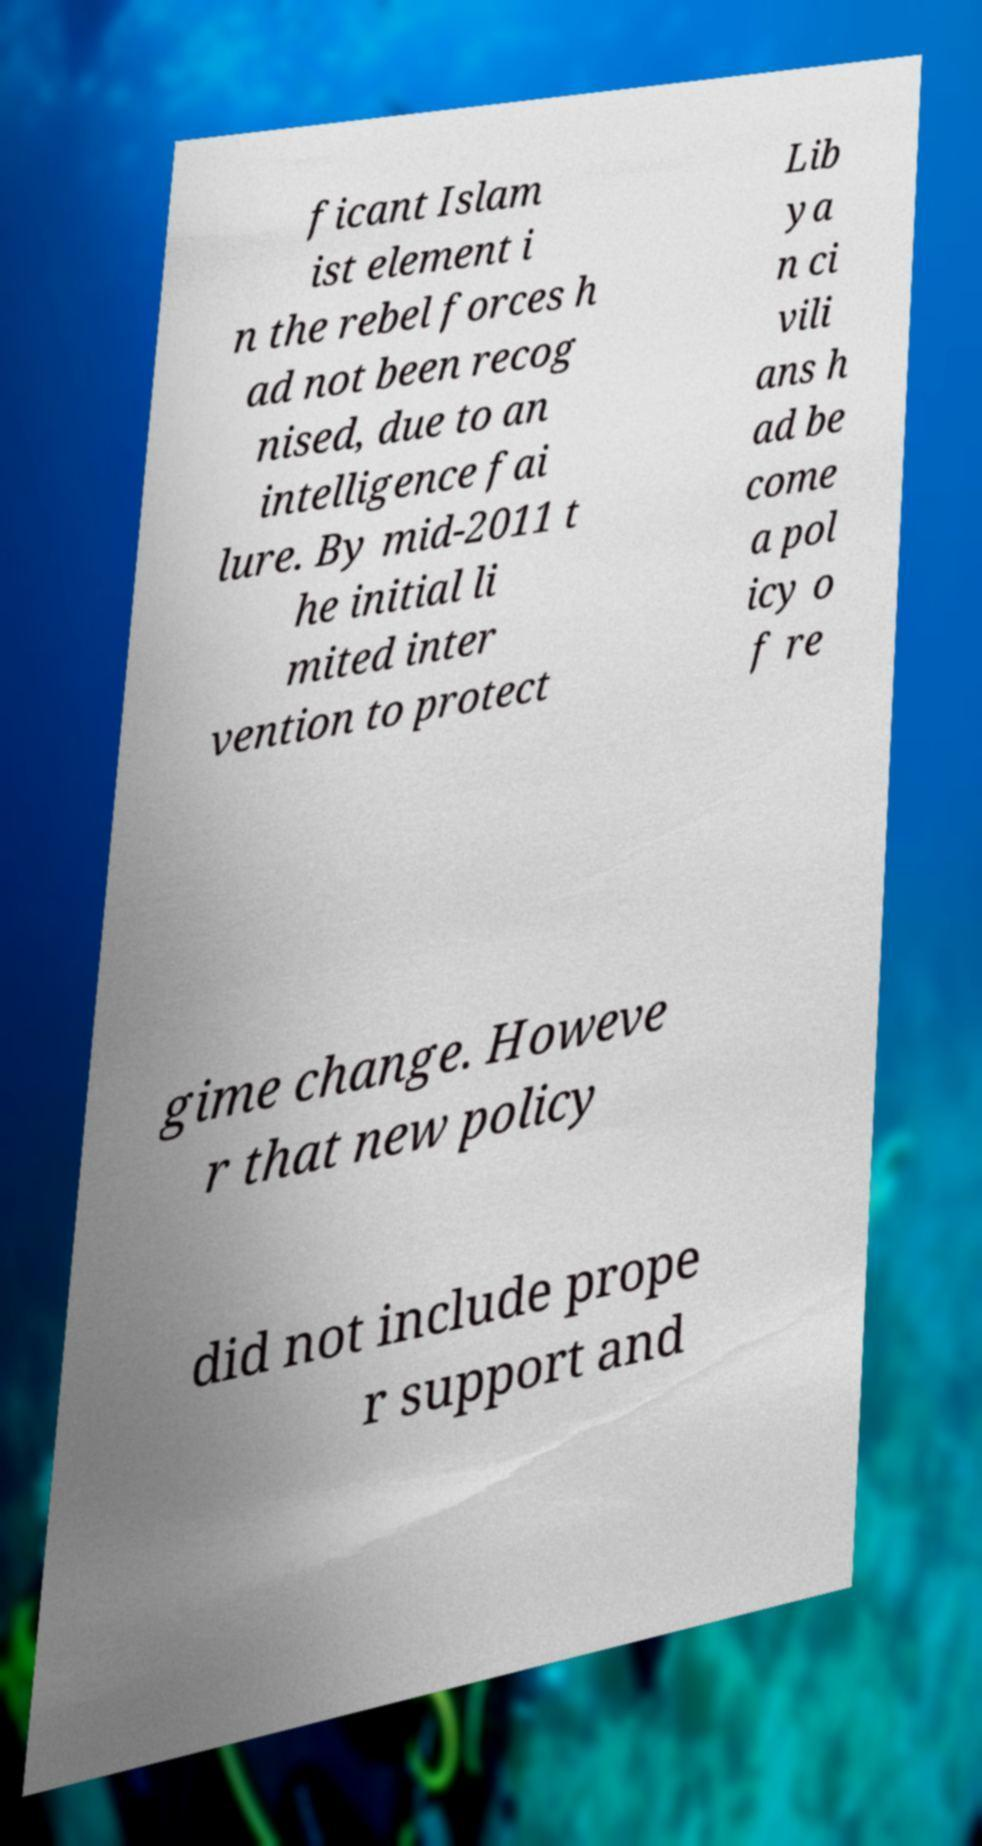Could you extract and type out the text from this image? ficant Islam ist element i n the rebel forces h ad not been recog nised, due to an intelligence fai lure. By mid-2011 t he initial li mited inter vention to protect Lib ya n ci vili ans h ad be come a pol icy o f re gime change. Howeve r that new policy did not include prope r support and 